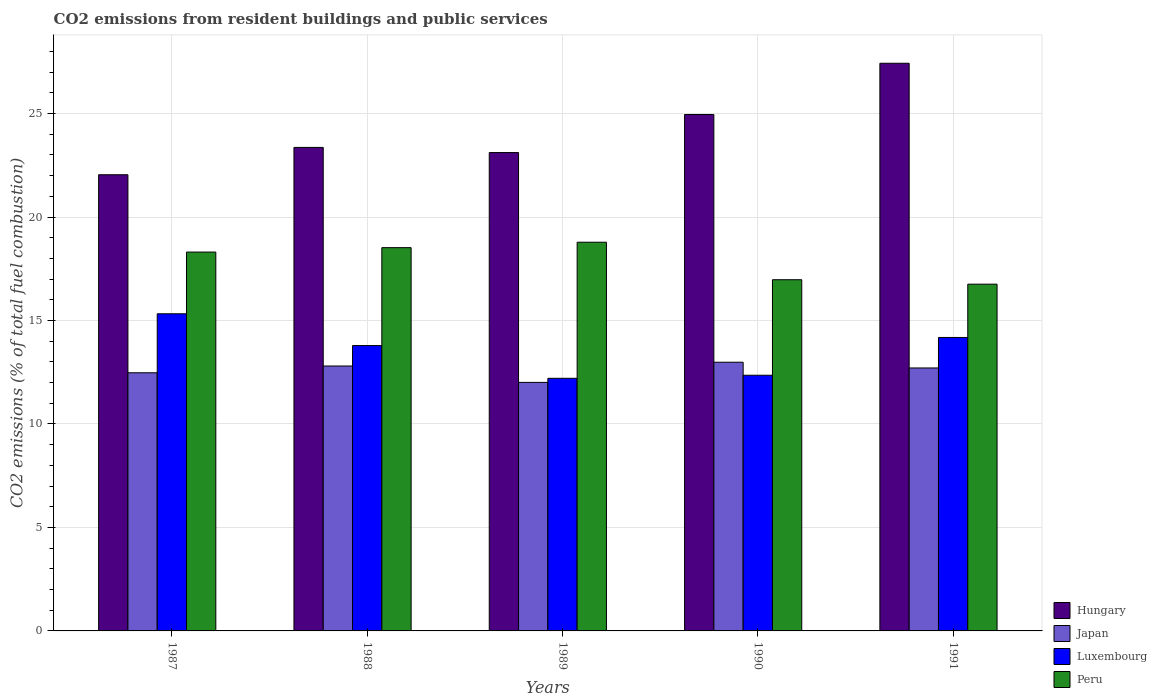How many groups of bars are there?
Offer a very short reply. 5. Are the number of bars per tick equal to the number of legend labels?
Keep it short and to the point. Yes. Are the number of bars on each tick of the X-axis equal?
Provide a succinct answer. Yes. How many bars are there on the 5th tick from the right?
Offer a terse response. 4. In how many cases, is the number of bars for a given year not equal to the number of legend labels?
Provide a succinct answer. 0. What is the total CO2 emitted in Peru in 1991?
Your answer should be very brief. 16.76. Across all years, what is the maximum total CO2 emitted in Luxembourg?
Keep it short and to the point. 15.33. Across all years, what is the minimum total CO2 emitted in Japan?
Offer a very short reply. 12.01. What is the total total CO2 emitted in Hungary in the graph?
Your answer should be compact. 120.91. What is the difference between the total CO2 emitted in Hungary in 1989 and that in 1991?
Your response must be concise. -4.32. What is the difference between the total CO2 emitted in Luxembourg in 1987 and the total CO2 emitted in Japan in 1991?
Your answer should be very brief. 2.62. What is the average total CO2 emitted in Japan per year?
Keep it short and to the point. 12.59. In the year 1990, what is the difference between the total CO2 emitted in Peru and total CO2 emitted in Japan?
Your answer should be compact. 3.99. In how many years, is the total CO2 emitted in Luxembourg greater than 14?
Keep it short and to the point. 2. What is the ratio of the total CO2 emitted in Japan in 1990 to that in 1991?
Offer a terse response. 1.02. Is the total CO2 emitted in Hungary in 1988 less than that in 1990?
Give a very brief answer. Yes. Is the difference between the total CO2 emitted in Peru in 1987 and 1989 greater than the difference between the total CO2 emitted in Japan in 1987 and 1989?
Ensure brevity in your answer.  No. What is the difference between the highest and the second highest total CO2 emitted in Peru?
Give a very brief answer. 0.26. What is the difference between the highest and the lowest total CO2 emitted in Luxembourg?
Offer a terse response. 3.12. Is the sum of the total CO2 emitted in Peru in 1987 and 1990 greater than the maximum total CO2 emitted in Luxembourg across all years?
Provide a short and direct response. Yes. Is it the case that in every year, the sum of the total CO2 emitted in Peru and total CO2 emitted in Luxembourg is greater than the sum of total CO2 emitted in Hungary and total CO2 emitted in Japan?
Ensure brevity in your answer.  Yes. What does the 1st bar from the left in 1988 represents?
Provide a short and direct response. Hungary. What does the 1st bar from the right in 1990 represents?
Offer a terse response. Peru. Are all the bars in the graph horizontal?
Provide a succinct answer. No. Are the values on the major ticks of Y-axis written in scientific E-notation?
Your answer should be compact. No. How are the legend labels stacked?
Give a very brief answer. Vertical. What is the title of the graph?
Your answer should be very brief. CO2 emissions from resident buildings and public services. Does "St. Martin (French part)" appear as one of the legend labels in the graph?
Provide a succinct answer. No. What is the label or title of the X-axis?
Offer a terse response. Years. What is the label or title of the Y-axis?
Keep it short and to the point. CO2 emissions (% of total fuel combustion). What is the CO2 emissions (% of total fuel combustion) in Hungary in 1987?
Provide a succinct answer. 22.04. What is the CO2 emissions (% of total fuel combustion) of Japan in 1987?
Your response must be concise. 12.47. What is the CO2 emissions (% of total fuel combustion) in Luxembourg in 1987?
Your response must be concise. 15.33. What is the CO2 emissions (% of total fuel combustion) of Peru in 1987?
Offer a very short reply. 18.31. What is the CO2 emissions (% of total fuel combustion) of Hungary in 1988?
Your response must be concise. 23.36. What is the CO2 emissions (% of total fuel combustion) of Japan in 1988?
Your answer should be very brief. 12.8. What is the CO2 emissions (% of total fuel combustion) in Luxembourg in 1988?
Your answer should be very brief. 13.79. What is the CO2 emissions (% of total fuel combustion) of Peru in 1988?
Your response must be concise. 18.52. What is the CO2 emissions (% of total fuel combustion) in Hungary in 1989?
Make the answer very short. 23.12. What is the CO2 emissions (% of total fuel combustion) of Japan in 1989?
Offer a terse response. 12.01. What is the CO2 emissions (% of total fuel combustion) in Luxembourg in 1989?
Give a very brief answer. 12.21. What is the CO2 emissions (% of total fuel combustion) in Peru in 1989?
Make the answer very short. 18.78. What is the CO2 emissions (% of total fuel combustion) in Hungary in 1990?
Ensure brevity in your answer.  24.95. What is the CO2 emissions (% of total fuel combustion) of Japan in 1990?
Your answer should be very brief. 12.98. What is the CO2 emissions (% of total fuel combustion) of Luxembourg in 1990?
Your answer should be very brief. 12.36. What is the CO2 emissions (% of total fuel combustion) of Peru in 1990?
Provide a short and direct response. 16.97. What is the CO2 emissions (% of total fuel combustion) of Hungary in 1991?
Give a very brief answer. 27.43. What is the CO2 emissions (% of total fuel combustion) in Japan in 1991?
Ensure brevity in your answer.  12.71. What is the CO2 emissions (% of total fuel combustion) in Luxembourg in 1991?
Provide a short and direct response. 14.18. What is the CO2 emissions (% of total fuel combustion) of Peru in 1991?
Your answer should be compact. 16.76. Across all years, what is the maximum CO2 emissions (% of total fuel combustion) in Hungary?
Your answer should be compact. 27.43. Across all years, what is the maximum CO2 emissions (% of total fuel combustion) of Japan?
Ensure brevity in your answer.  12.98. Across all years, what is the maximum CO2 emissions (% of total fuel combustion) in Luxembourg?
Your answer should be compact. 15.33. Across all years, what is the maximum CO2 emissions (% of total fuel combustion) in Peru?
Provide a succinct answer. 18.78. Across all years, what is the minimum CO2 emissions (% of total fuel combustion) in Hungary?
Ensure brevity in your answer.  22.04. Across all years, what is the minimum CO2 emissions (% of total fuel combustion) of Japan?
Offer a very short reply. 12.01. Across all years, what is the minimum CO2 emissions (% of total fuel combustion) in Luxembourg?
Keep it short and to the point. 12.21. Across all years, what is the minimum CO2 emissions (% of total fuel combustion) of Peru?
Give a very brief answer. 16.76. What is the total CO2 emissions (% of total fuel combustion) of Hungary in the graph?
Your answer should be compact. 120.91. What is the total CO2 emissions (% of total fuel combustion) in Japan in the graph?
Your answer should be compact. 62.97. What is the total CO2 emissions (% of total fuel combustion) of Luxembourg in the graph?
Ensure brevity in your answer.  67.86. What is the total CO2 emissions (% of total fuel combustion) of Peru in the graph?
Your response must be concise. 89.34. What is the difference between the CO2 emissions (% of total fuel combustion) in Hungary in 1987 and that in 1988?
Provide a succinct answer. -1.32. What is the difference between the CO2 emissions (% of total fuel combustion) in Japan in 1987 and that in 1988?
Provide a short and direct response. -0.33. What is the difference between the CO2 emissions (% of total fuel combustion) of Luxembourg in 1987 and that in 1988?
Your response must be concise. 1.54. What is the difference between the CO2 emissions (% of total fuel combustion) in Peru in 1987 and that in 1988?
Your answer should be very brief. -0.21. What is the difference between the CO2 emissions (% of total fuel combustion) in Hungary in 1987 and that in 1989?
Offer a terse response. -1.07. What is the difference between the CO2 emissions (% of total fuel combustion) in Japan in 1987 and that in 1989?
Give a very brief answer. 0.46. What is the difference between the CO2 emissions (% of total fuel combustion) in Luxembourg in 1987 and that in 1989?
Give a very brief answer. 3.12. What is the difference between the CO2 emissions (% of total fuel combustion) in Peru in 1987 and that in 1989?
Give a very brief answer. -0.48. What is the difference between the CO2 emissions (% of total fuel combustion) in Hungary in 1987 and that in 1990?
Offer a terse response. -2.91. What is the difference between the CO2 emissions (% of total fuel combustion) of Japan in 1987 and that in 1990?
Provide a succinct answer. -0.51. What is the difference between the CO2 emissions (% of total fuel combustion) in Luxembourg in 1987 and that in 1990?
Give a very brief answer. 2.97. What is the difference between the CO2 emissions (% of total fuel combustion) of Peru in 1987 and that in 1990?
Make the answer very short. 1.34. What is the difference between the CO2 emissions (% of total fuel combustion) in Hungary in 1987 and that in 1991?
Give a very brief answer. -5.39. What is the difference between the CO2 emissions (% of total fuel combustion) of Japan in 1987 and that in 1991?
Your response must be concise. -0.23. What is the difference between the CO2 emissions (% of total fuel combustion) in Luxembourg in 1987 and that in 1991?
Your answer should be compact. 1.14. What is the difference between the CO2 emissions (% of total fuel combustion) of Peru in 1987 and that in 1991?
Offer a terse response. 1.55. What is the difference between the CO2 emissions (% of total fuel combustion) of Hungary in 1988 and that in 1989?
Your response must be concise. 0.25. What is the difference between the CO2 emissions (% of total fuel combustion) in Japan in 1988 and that in 1989?
Your answer should be compact. 0.79. What is the difference between the CO2 emissions (% of total fuel combustion) in Luxembourg in 1988 and that in 1989?
Your answer should be compact. 1.58. What is the difference between the CO2 emissions (% of total fuel combustion) in Peru in 1988 and that in 1989?
Keep it short and to the point. -0.26. What is the difference between the CO2 emissions (% of total fuel combustion) of Hungary in 1988 and that in 1990?
Offer a very short reply. -1.59. What is the difference between the CO2 emissions (% of total fuel combustion) in Japan in 1988 and that in 1990?
Your answer should be compact. -0.18. What is the difference between the CO2 emissions (% of total fuel combustion) of Luxembourg in 1988 and that in 1990?
Provide a short and direct response. 1.43. What is the difference between the CO2 emissions (% of total fuel combustion) of Peru in 1988 and that in 1990?
Give a very brief answer. 1.55. What is the difference between the CO2 emissions (% of total fuel combustion) of Hungary in 1988 and that in 1991?
Your answer should be compact. -4.07. What is the difference between the CO2 emissions (% of total fuel combustion) of Japan in 1988 and that in 1991?
Your answer should be compact. 0.09. What is the difference between the CO2 emissions (% of total fuel combustion) of Luxembourg in 1988 and that in 1991?
Make the answer very short. -0.39. What is the difference between the CO2 emissions (% of total fuel combustion) of Peru in 1988 and that in 1991?
Ensure brevity in your answer.  1.76. What is the difference between the CO2 emissions (% of total fuel combustion) in Hungary in 1989 and that in 1990?
Keep it short and to the point. -1.84. What is the difference between the CO2 emissions (% of total fuel combustion) in Japan in 1989 and that in 1990?
Provide a short and direct response. -0.97. What is the difference between the CO2 emissions (% of total fuel combustion) in Luxembourg in 1989 and that in 1990?
Provide a short and direct response. -0.15. What is the difference between the CO2 emissions (% of total fuel combustion) of Peru in 1989 and that in 1990?
Offer a terse response. 1.81. What is the difference between the CO2 emissions (% of total fuel combustion) in Hungary in 1989 and that in 1991?
Make the answer very short. -4.32. What is the difference between the CO2 emissions (% of total fuel combustion) of Japan in 1989 and that in 1991?
Keep it short and to the point. -0.7. What is the difference between the CO2 emissions (% of total fuel combustion) in Luxembourg in 1989 and that in 1991?
Offer a terse response. -1.97. What is the difference between the CO2 emissions (% of total fuel combustion) in Peru in 1989 and that in 1991?
Ensure brevity in your answer.  2.03. What is the difference between the CO2 emissions (% of total fuel combustion) of Hungary in 1990 and that in 1991?
Offer a terse response. -2.48. What is the difference between the CO2 emissions (% of total fuel combustion) of Japan in 1990 and that in 1991?
Give a very brief answer. 0.28. What is the difference between the CO2 emissions (% of total fuel combustion) of Luxembourg in 1990 and that in 1991?
Ensure brevity in your answer.  -1.83. What is the difference between the CO2 emissions (% of total fuel combustion) in Peru in 1990 and that in 1991?
Give a very brief answer. 0.21. What is the difference between the CO2 emissions (% of total fuel combustion) of Hungary in 1987 and the CO2 emissions (% of total fuel combustion) of Japan in 1988?
Offer a very short reply. 9.24. What is the difference between the CO2 emissions (% of total fuel combustion) in Hungary in 1987 and the CO2 emissions (% of total fuel combustion) in Luxembourg in 1988?
Your response must be concise. 8.25. What is the difference between the CO2 emissions (% of total fuel combustion) in Hungary in 1987 and the CO2 emissions (% of total fuel combustion) in Peru in 1988?
Keep it short and to the point. 3.52. What is the difference between the CO2 emissions (% of total fuel combustion) in Japan in 1987 and the CO2 emissions (% of total fuel combustion) in Luxembourg in 1988?
Offer a terse response. -1.32. What is the difference between the CO2 emissions (% of total fuel combustion) in Japan in 1987 and the CO2 emissions (% of total fuel combustion) in Peru in 1988?
Ensure brevity in your answer.  -6.05. What is the difference between the CO2 emissions (% of total fuel combustion) in Luxembourg in 1987 and the CO2 emissions (% of total fuel combustion) in Peru in 1988?
Offer a terse response. -3.19. What is the difference between the CO2 emissions (% of total fuel combustion) in Hungary in 1987 and the CO2 emissions (% of total fuel combustion) in Japan in 1989?
Offer a very short reply. 10.03. What is the difference between the CO2 emissions (% of total fuel combustion) of Hungary in 1987 and the CO2 emissions (% of total fuel combustion) of Luxembourg in 1989?
Provide a succinct answer. 9.84. What is the difference between the CO2 emissions (% of total fuel combustion) of Hungary in 1987 and the CO2 emissions (% of total fuel combustion) of Peru in 1989?
Provide a short and direct response. 3.26. What is the difference between the CO2 emissions (% of total fuel combustion) of Japan in 1987 and the CO2 emissions (% of total fuel combustion) of Luxembourg in 1989?
Your response must be concise. 0.27. What is the difference between the CO2 emissions (% of total fuel combustion) in Japan in 1987 and the CO2 emissions (% of total fuel combustion) in Peru in 1989?
Provide a short and direct response. -6.31. What is the difference between the CO2 emissions (% of total fuel combustion) of Luxembourg in 1987 and the CO2 emissions (% of total fuel combustion) of Peru in 1989?
Offer a very short reply. -3.46. What is the difference between the CO2 emissions (% of total fuel combustion) of Hungary in 1987 and the CO2 emissions (% of total fuel combustion) of Japan in 1990?
Provide a succinct answer. 9.06. What is the difference between the CO2 emissions (% of total fuel combustion) of Hungary in 1987 and the CO2 emissions (% of total fuel combustion) of Luxembourg in 1990?
Make the answer very short. 9.69. What is the difference between the CO2 emissions (% of total fuel combustion) of Hungary in 1987 and the CO2 emissions (% of total fuel combustion) of Peru in 1990?
Ensure brevity in your answer.  5.07. What is the difference between the CO2 emissions (% of total fuel combustion) of Japan in 1987 and the CO2 emissions (% of total fuel combustion) of Luxembourg in 1990?
Make the answer very short. 0.12. What is the difference between the CO2 emissions (% of total fuel combustion) of Japan in 1987 and the CO2 emissions (% of total fuel combustion) of Peru in 1990?
Give a very brief answer. -4.5. What is the difference between the CO2 emissions (% of total fuel combustion) in Luxembourg in 1987 and the CO2 emissions (% of total fuel combustion) in Peru in 1990?
Provide a short and direct response. -1.65. What is the difference between the CO2 emissions (% of total fuel combustion) of Hungary in 1987 and the CO2 emissions (% of total fuel combustion) of Japan in 1991?
Ensure brevity in your answer.  9.34. What is the difference between the CO2 emissions (% of total fuel combustion) of Hungary in 1987 and the CO2 emissions (% of total fuel combustion) of Luxembourg in 1991?
Make the answer very short. 7.86. What is the difference between the CO2 emissions (% of total fuel combustion) in Hungary in 1987 and the CO2 emissions (% of total fuel combustion) in Peru in 1991?
Offer a very short reply. 5.29. What is the difference between the CO2 emissions (% of total fuel combustion) in Japan in 1987 and the CO2 emissions (% of total fuel combustion) in Luxembourg in 1991?
Keep it short and to the point. -1.71. What is the difference between the CO2 emissions (% of total fuel combustion) in Japan in 1987 and the CO2 emissions (% of total fuel combustion) in Peru in 1991?
Your answer should be very brief. -4.28. What is the difference between the CO2 emissions (% of total fuel combustion) in Luxembourg in 1987 and the CO2 emissions (% of total fuel combustion) in Peru in 1991?
Keep it short and to the point. -1.43. What is the difference between the CO2 emissions (% of total fuel combustion) of Hungary in 1988 and the CO2 emissions (% of total fuel combustion) of Japan in 1989?
Give a very brief answer. 11.35. What is the difference between the CO2 emissions (% of total fuel combustion) of Hungary in 1988 and the CO2 emissions (% of total fuel combustion) of Luxembourg in 1989?
Ensure brevity in your answer.  11.16. What is the difference between the CO2 emissions (% of total fuel combustion) of Hungary in 1988 and the CO2 emissions (% of total fuel combustion) of Peru in 1989?
Provide a succinct answer. 4.58. What is the difference between the CO2 emissions (% of total fuel combustion) in Japan in 1988 and the CO2 emissions (% of total fuel combustion) in Luxembourg in 1989?
Keep it short and to the point. 0.59. What is the difference between the CO2 emissions (% of total fuel combustion) in Japan in 1988 and the CO2 emissions (% of total fuel combustion) in Peru in 1989?
Your answer should be compact. -5.98. What is the difference between the CO2 emissions (% of total fuel combustion) in Luxembourg in 1988 and the CO2 emissions (% of total fuel combustion) in Peru in 1989?
Your answer should be compact. -4.99. What is the difference between the CO2 emissions (% of total fuel combustion) in Hungary in 1988 and the CO2 emissions (% of total fuel combustion) in Japan in 1990?
Provide a succinct answer. 10.38. What is the difference between the CO2 emissions (% of total fuel combustion) in Hungary in 1988 and the CO2 emissions (% of total fuel combustion) in Luxembourg in 1990?
Provide a short and direct response. 11.01. What is the difference between the CO2 emissions (% of total fuel combustion) of Hungary in 1988 and the CO2 emissions (% of total fuel combustion) of Peru in 1990?
Your answer should be very brief. 6.39. What is the difference between the CO2 emissions (% of total fuel combustion) of Japan in 1988 and the CO2 emissions (% of total fuel combustion) of Luxembourg in 1990?
Your answer should be very brief. 0.45. What is the difference between the CO2 emissions (% of total fuel combustion) of Japan in 1988 and the CO2 emissions (% of total fuel combustion) of Peru in 1990?
Ensure brevity in your answer.  -4.17. What is the difference between the CO2 emissions (% of total fuel combustion) in Luxembourg in 1988 and the CO2 emissions (% of total fuel combustion) in Peru in 1990?
Give a very brief answer. -3.18. What is the difference between the CO2 emissions (% of total fuel combustion) of Hungary in 1988 and the CO2 emissions (% of total fuel combustion) of Japan in 1991?
Make the answer very short. 10.66. What is the difference between the CO2 emissions (% of total fuel combustion) in Hungary in 1988 and the CO2 emissions (% of total fuel combustion) in Luxembourg in 1991?
Provide a succinct answer. 9.18. What is the difference between the CO2 emissions (% of total fuel combustion) in Hungary in 1988 and the CO2 emissions (% of total fuel combustion) in Peru in 1991?
Offer a terse response. 6.61. What is the difference between the CO2 emissions (% of total fuel combustion) of Japan in 1988 and the CO2 emissions (% of total fuel combustion) of Luxembourg in 1991?
Offer a very short reply. -1.38. What is the difference between the CO2 emissions (% of total fuel combustion) of Japan in 1988 and the CO2 emissions (% of total fuel combustion) of Peru in 1991?
Give a very brief answer. -3.95. What is the difference between the CO2 emissions (% of total fuel combustion) of Luxembourg in 1988 and the CO2 emissions (% of total fuel combustion) of Peru in 1991?
Offer a very short reply. -2.97. What is the difference between the CO2 emissions (% of total fuel combustion) in Hungary in 1989 and the CO2 emissions (% of total fuel combustion) in Japan in 1990?
Offer a very short reply. 10.13. What is the difference between the CO2 emissions (% of total fuel combustion) in Hungary in 1989 and the CO2 emissions (% of total fuel combustion) in Luxembourg in 1990?
Your response must be concise. 10.76. What is the difference between the CO2 emissions (% of total fuel combustion) of Hungary in 1989 and the CO2 emissions (% of total fuel combustion) of Peru in 1990?
Offer a very short reply. 6.14. What is the difference between the CO2 emissions (% of total fuel combustion) in Japan in 1989 and the CO2 emissions (% of total fuel combustion) in Luxembourg in 1990?
Make the answer very short. -0.35. What is the difference between the CO2 emissions (% of total fuel combustion) of Japan in 1989 and the CO2 emissions (% of total fuel combustion) of Peru in 1990?
Make the answer very short. -4.96. What is the difference between the CO2 emissions (% of total fuel combustion) of Luxembourg in 1989 and the CO2 emissions (% of total fuel combustion) of Peru in 1990?
Provide a short and direct response. -4.76. What is the difference between the CO2 emissions (% of total fuel combustion) of Hungary in 1989 and the CO2 emissions (% of total fuel combustion) of Japan in 1991?
Make the answer very short. 10.41. What is the difference between the CO2 emissions (% of total fuel combustion) of Hungary in 1989 and the CO2 emissions (% of total fuel combustion) of Luxembourg in 1991?
Offer a very short reply. 8.93. What is the difference between the CO2 emissions (% of total fuel combustion) in Hungary in 1989 and the CO2 emissions (% of total fuel combustion) in Peru in 1991?
Your answer should be compact. 6.36. What is the difference between the CO2 emissions (% of total fuel combustion) of Japan in 1989 and the CO2 emissions (% of total fuel combustion) of Luxembourg in 1991?
Make the answer very short. -2.17. What is the difference between the CO2 emissions (% of total fuel combustion) of Japan in 1989 and the CO2 emissions (% of total fuel combustion) of Peru in 1991?
Offer a terse response. -4.75. What is the difference between the CO2 emissions (% of total fuel combustion) of Luxembourg in 1989 and the CO2 emissions (% of total fuel combustion) of Peru in 1991?
Provide a succinct answer. -4.55. What is the difference between the CO2 emissions (% of total fuel combustion) of Hungary in 1990 and the CO2 emissions (% of total fuel combustion) of Japan in 1991?
Provide a short and direct response. 12.25. What is the difference between the CO2 emissions (% of total fuel combustion) of Hungary in 1990 and the CO2 emissions (% of total fuel combustion) of Luxembourg in 1991?
Offer a very short reply. 10.77. What is the difference between the CO2 emissions (% of total fuel combustion) of Hungary in 1990 and the CO2 emissions (% of total fuel combustion) of Peru in 1991?
Give a very brief answer. 8.2. What is the difference between the CO2 emissions (% of total fuel combustion) of Japan in 1990 and the CO2 emissions (% of total fuel combustion) of Luxembourg in 1991?
Provide a short and direct response. -1.2. What is the difference between the CO2 emissions (% of total fuel combustion) in Japan in 1990 and the CO2 emissions (% of total fuel combustion) in Peru in 1991?
Ensure brevity in your answer.  -3.77. What is the difference between the CO2 emissions (% of total fuel combustion) in Luxembourg in 1990 and the CO2 emissions (% of total fuel combustion) in Peru in 1991?
Your answer should be very brief. -4.4. What is the average CO2 emissions (% of total fuel combustion) of Hungary per year?
Provide a succinct answer. 24.18. What is the average CO2 emissions (% of total fuel combustion) of Japan per year?
Ensure brevity in your answer.  12.6. What is the average CO2 emissions (% of total fuel combustion) in Luxembourg per year?
Your answer should be very brief. 13.57. What is the average CO2 emissions (% of total fuel combustion) in Peru per year?
Give a very brief answer. 17.87. In the year 1987, what is the difference between the CO2 emissions (% of total fuel combustion) in Hungary and CO2 emissions (% of total fuel combustion) in Japan?
Your answer should be very brief. 9.57. In the year 1987, what is the difference between the CO2 emissions (% of total fuel combustion) in Hungary and CO2 emissions (% of total fuel combustion) in Luxembourg?
Give a very brief answer. 6.72. In the year 1987, what is the difference between the CO2 emissions (% of total fuel combustion) in Hungary and CO2 emissions (% of total fuel combustion) in Peru?
Give a very brief answer. 3.74. In the year 1987, what is the difference between the CO2 emissions (% of total fuel combustion) in Japan and CO2 emissions (% of total fuel combustion) in Luxembourg?
Offer a very short reply. -2.85. In the year 1987, what is the difference between the CO2 emissions (% of total fuel combustion) in Japan and CO2 emissions (% of total fuel combustion) in Peru?
Offer a terse response. -5.83. In the year 1987, what is the difference between the CO2 emissions (% of total fuel combustion) in Luxembourg and CO2 emissions (% of total fuel combustion) in Peru?
Your response must be concise. -2.98. In the year 1988, what is the difference between the CO2 emissions (% of total fuel combustion) of Hungary and CO2 emissions (% of total fuel combustion) of Japan?
Your answer should be compact. 10.56. In the year 1988, what is the difference between the CO2 emissions (% of total fuel combustion) of Hungary and CO2 emissions (% of total fuel combustion) of Luxembourg?
Keep it short and to the point. 9.57. In the year 1988, what is the difference between the CO2 emissions (% of total fuel combustion) in Hungary and CO2 emissions (% of total fuel combustion) in Peru?
Your response must be concise. 4.84. In the year 1988, what is the difference between the CO2 emissions (% of total fuel combustion) in Japan and CO2 emissions (% of total fuel combustion) in Luxembourg?
Offer a very short reply. -0.99. In the year 1988, what is the difference between the CO2 emissions (% of total fuel combustion) in Japan and CO2 emissions (% of total fuel combustion) in Peru?
Ensure brevity in your answer.  -5.72. In the year 1988, what is the difference between the CO2 emissions (% of total fuel combustion) in Luxembourg and CO2 emissions (% of total fuel combustion) in Peru?
Offer a very short reply. -4.73. In the year 1989, what is the difference between the CO2 emissions (% of total fuel combustion) in Hungary and CO2 emissions (% of total fuel combustion) in Japan?
Make the answer very short. 11.11. In the year 1989, what is the difference between the CO2 emissions (% of total fuel combustion) in Hungary and CO2 emissions (% of total fuel combustion) in Luxembourg?
Provide a short and direct response. 10.91. In the year 1989, what is the difference between the CO2 emissions (% of total fuel combustion) in Hungary and CO2 emissions (% of total fuel combustion) in Peru?
Make the answer very short. 4.33. In the year 1989, what is the difference between the CO2 emissions (% of total fuel combustion) in Japan and CO2 emissions (% of total fuel combustion) in Luxembourg?
Your response must be concise. -0.2. In the year 1989, what is the difference between the CO2 emissions (% of total fuel combustion) in Japan and CO2 emissions (% of total fuel combustion) in Peru?
Make the answer very short. -6.77. In the year 1989, what is the difference between the CO2 emissions (% of total fuel combustion) in Luxembourg and CO2 emissions (% of total fuel combustion) in Peru?
Offer a terse response. -6.58. In the year 1990, what is the difference between the CO2 emissions (% of total fuel combustion) in Hungary and CO2 emissions (% of total fuel combustion) in Japan?
Your answer should be very brief. 11.97. In the year 1990, what is the difference between the CO2 emissions (% of total fuel combustion) of Hungary and CO2 emissions (% of total fuel combustion) of Luxembourg?
Offer a very short reply. 12.6. In the year 1990, what is the difference between the CO2 emissions (% of total fuel combustion) in Hungary and CO2 emissions (% of total fuel combustion) in Peru?
Your answer should be compact. 7.98. In the year 1990, what is the difference between the CO2 emissions (% of total fuel combustion) of Japan and CO2 emissions (% of total fuel combustion) of Luxembourg?
Ensure brevity in your answer.  0.63. In the year 1990, what is the difference between the CO2 emissions (% of total fuel combustion) in Japan and CO2 emissions (% of total fuel combustion) in Peru?
Your answer should be very brief. -3.99. In the year 1990, what is the difference between the CO2 emissions (% of total fuel combustion) of Luxembourg and CO2 emissions (% of total fuel combustion) of Peru?
Offer a terse response. -4.62. In the year 1991, what is the difference between the CO2 emissions (% of total fuel combustion) of Hungary and CO2 emissions (% of total fuel combustion) of Japan?
Your response must be concise. 14.72. In the year 1991, what is the difference between the CO2 emissions (% of total fuel combustion) in Hungary and CO2 emissions (% of total fuel combustion) in Luxembourg?
Make the answer very short. 13.25. In the year 1991, what is the difference between the CO2 emissions (% of total fuel combustion) of Hungary and CO2 emissions (% of total fuel combustion) of Peru?
Offer a very short reply. 10.67. In the year 1991, what is the difference between the CO2 emissions (% of total fuel combustion) in Japan and CO2 emissions (% of total fuel combustion) in Luxembourg?
Offer a terse response. -1.47. In the year 1991, what is the difference between the CO2 emissions (% of total fuel combustion) in Japan and CO2 emissions (% of total fuel combustion) in Peru?
Provide a short and direct response. -4.05. In the year 1991, what is the difference between the CO2 emissions (% of total fuel combustion) in Luxembourg and CO2 emissions (% of total fuel combustion) in Peru?
Your answer should be compact. -2.58. What is the ratio of the CO2 emissions (% of total fuel combustion) of Hungary in 1987 to that in 1988?
Your answer should be compact. 0.94. What is the ratio of the CO2 emissions (% of total fuel combustion) of Japan in 1987 to that in 1988?
Give a very brief answer. 0.97. What is the ratio of the CO2 emissions (% of total fuel combustion) of Luxembourg in 1987 to that in 1988?
Ensure brevity in your answer.  1.11. What is the ratio of the CO2 emissions (% of total fuel combustion) in Peru in 1987 to that in 1988?
Keep it short and to the point. 0.99. What is the ratio of the CO2 emissions (% of total fuel combustion) in Hungary in 1987 to that in 1989?
Your answer should be compact. 0.95. What is the ratio of the CO2 emissions (% of total fuel combustion) in Japan in 1987 to that in 1989?
Keep it short and to the point. 1.04. What is the ratio of the CO2 emissions (% of total fuel combustion) in Luxembourg in 1987 to that in 1989?
Your answer should be very brief. 1.26. What is the ratio of the CO2 emissions (% of total fuel combustion) of Peru in 1987 to that in 1989?
Your answer should be compact. 0.97. What is the ratio of the CO2 emissions (% of total fuel combustion) in Hungary in 1987 to that in 1990?
Keep it short and to the point. 0.88. What is the ratio of the CO2 emissions (% of total fuel combustion) of Japan in 1987 to that in 1990?
Keep it short and to the point. 0.96. What is the ratio of the CO2 emissions (% of total fuel combustion) in Luxembourg in 1987 to that in 1990?
Provide a succinct answer. 1.24. What is the ratio of the CO2 emissions (% of total fuel combustion) in Peru in 1987 to that in 1990?
Your answer should be very brief. 1.08. What is the ratio of the CO2 emissions (% of total fuel combustion) of Hungary in 1987 to that in 1991?
Provide a succinct answer. 0.8. What is the ratio of the CO2 emissions (% of total fuel combustion) of Japan in 1987 to that in 1991?
Offer a terse response. 0.98. What is the ratio of the CO2 emissions (% of total fuel combustion) in Luxembourg in 1987 to that in 1991?
Give a very brief answer. 1.08. What is the ratio of the CO2 emissions (% of total fuel combustion) in Peru in 1987 to that in 1991?
Offer a terse response. 1.09. What is the ratio of the CO2 emissions (% of total fuel combustion) in Hungary in 1988 to that in 1989?
Ensure brevity in your answer.  1.01. What is the ratio of the CO2 emissions (% of total fuel combustion) of Japan in 1988 to that in 1989?
Your answer should be very brief. 1.07. What is the ratio of the CO2 emissions (% of total fuel combustion) of Luxembourg in 1988 to that in 1989?
Your response must be concise. 1.13. What is the ratio of the CO2 emissions (% of total fuel combustion) in Peru in 1988 to that in 1989?
Offer a very short reply. 0.99. What is the ratio of the CO2 emissions (% of total fuel combustion) in Hungary in 1988 to that in 1990?
Your answer should be very brief. 0.94. What is the ratio of the CO2 emissions (% of total fuel combustion) in Japan in 1988 to that in 1990?
Your answer should be compact. 0.99. What is the ratio of the CO2 emissions (% of total fuel combustion) in Luxembourg in 1988 to that in 1990?
Ensure brevity in your answer.  1.12. What is the ratio of the CO2 emissions (% of total fuel combustion) in Peru in 1988 to that in 1990?
Your answer should be compact. 1.09. What is the ratio of the CO2 emissions (% of total fuel combustion) in Hungary in 1988 to that in 1991?
Provide a succinct answer. 0.85. What is the ratio of the CO2 emissions (% of total fuel combustion) in Japan in 1988 to that in 1991?
Give a very brief answer. 1.01. What is the ratio of the CO2 emissions (% of total fuel combustion) in Luxembourg in 1988 to that in 1991?
Give a very brief answer. 0.97. What is the ratio of the CO2 emissions (% of total fuel combustion) of Peru in 1988 to that in 1991?
Your answer should be very brief. 1.11. What is the ratio of the CO2 emissions (% of total fuel combustion) of Hungary in 1989 to that in 1990?
Your response must be concise. 0.93. What is the ratio of the CO2 emissions (% of total fuel combustion) of Japan in 1989 to that in 1990?
Your answer should be very brief. 0.92. What is the ratio of the CO2 emissions (% of total fuel combustion) of Peru in 1989 to that in 1990?
Give a very brief answer. 1.11. What is the ratio of the CO2 emissions (% of total fuel combustion) in Hungary in 1989 to that in 1991?
Offer a terse response. 0.84. What is the ratio of the CO2 emissions (% of total fuel combustion) in Japan in 1989 to that in 1991?
Keep it short and to the point. 0.95. What is the ratio of the CO2 emissions (% of total fuel combustion) of Luxembourg in 1989 to that in 1991?
Offer a very short reply. 0.86. What is the ratio of the CO2 emissions (% of total fuel combustion) of Peru in 1989 to that in 1991?
Keep it short and to the point. 1.12. What is the ratio of the CO2 emissions (% of total fuel combustion) in Hungary in 1990 to that in 1991?
Ensure brevity in your answer.  0.91. What is the ratio of the CO2 emissions (% of total fuel combustion) in Japan in 1990 to that in 1991?
Your response must be concise. 1.02. What is the ratio of the CO2 emissions (% of total fuel combustion) in Luxembourg in 1990 to that in 1991?
Offer a very short reply. 0.87. What is the ratio of the CO2 emissions (% of total fuel combustion) of Peru in 1990 to that in 1991?
Provide a short and direct response. 1.01. What is the difference between the highest and the second highest CO2 emissions (% of total fuel combustion) in Hungary?
Provide a short and direct response. 2.48. What is the difference between the highest and the second highest CO2 emissions (% of total fuel combustion) of Japan?
Your answer should be very brief. 0.18. What is the difference between the highest and the second highest CO2 emissions (% of total fuel combustion) of Luxembourg?
Your answer should be compact. 1.14. What is the difference between the highest and the second highest CO2 emissions (% of total fuel combustion) in Peru?
Your answer should be very brief. 0.26. What is the difference between the highest and the lowest CO2 emissions (% of total fuel combustion) in Hungary?
Your response must be concise. 5.39. What is the difference between the highest and the lowest CO2 emissions (% of total fuel combustion) of Japan?
Your response must be concise. 0.97. What is the difference between the highest and the lowest CO2 emissions (% of total fuel combustion) of Luxembourg?
Provide a short and direct response. 3.12. What is the difference between the highest and the lowest CO2 emissions (% of total fuel combustion) of Peru?
Offer a terse response. 2.03. 